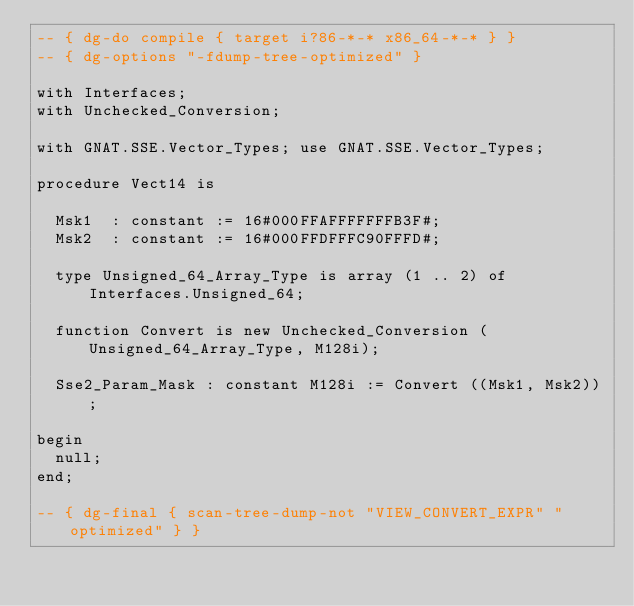<code> <loc_0><loc_0><loc_500><loc_500><_Ada_>-- { dg-do compile { target i?86-*-* x86_64-*-* } }
-- { dg-options "-fdump-tree-optimized" }

with Interfaces;
with Unchecked_Conversion;

with GNAT.SSE.Vector_Types; use GNAT.SSE.Vector_Types;

procedure Vect14 is

  Msk1  : constant := 16#000FFAFFFFFFFB3F#;
  Msk2  : constant := 16#000FFDFFFC90FFFD#;

  type Unsigned_64_Array_Type is array (1 .. 2) of Interfaces.Unsigned_64;

  function Convert is new Unchecked_Conversion (Unsigned_64_Array_Type, M128i);

  Sse2_Param_Mask : constant M128i := Convert ((Msk1, Msk2));

begin
  null;
end;

-- { dg-final { scan-tree-dump-not "VIEW_CONVERT_EXPR" "optimized" } }
</code> 